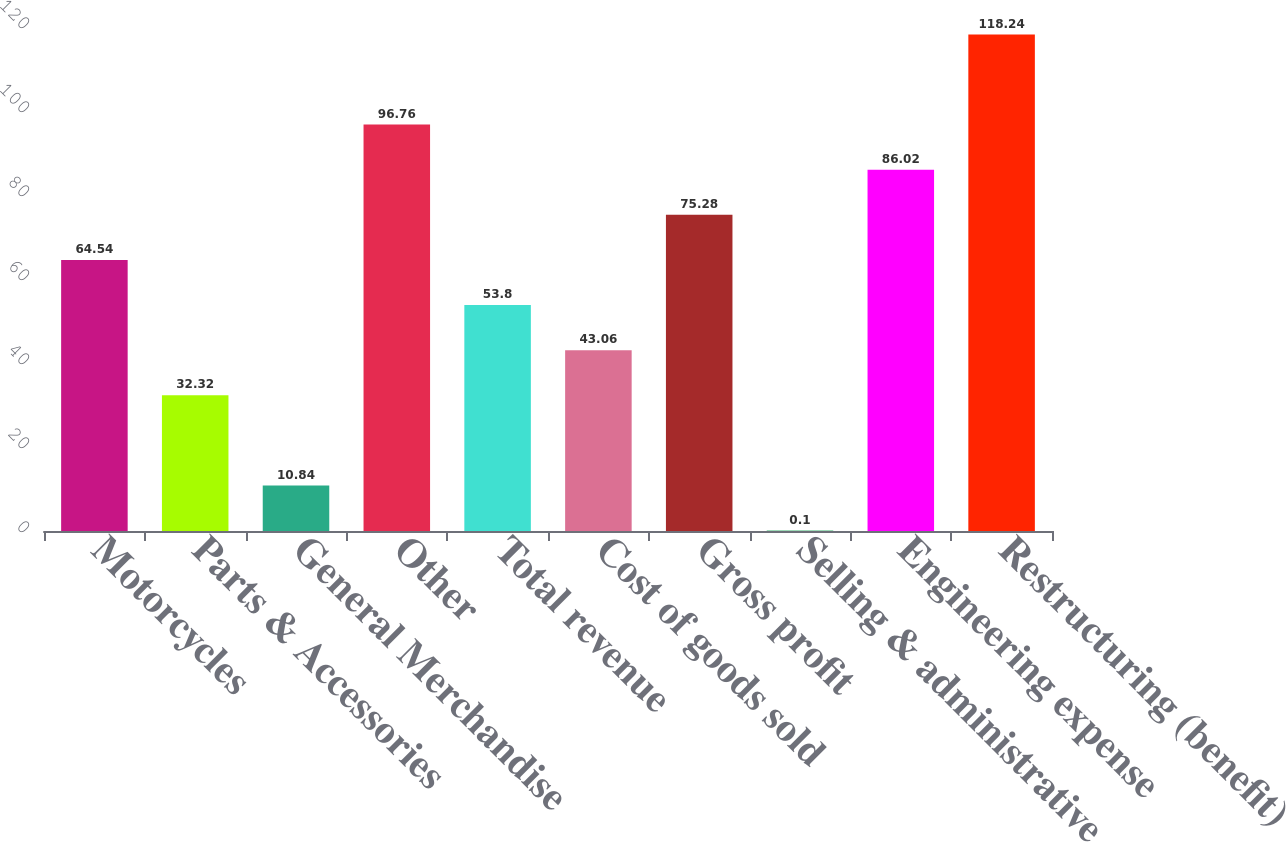Convert chart. <chart><loc_0><loc_0><loc_500><loc_500><bar_chart><fcel>Motorcycles<fcel>Parts & Accessories<fcel>General Merchandise<fcel>Other<fcel>Total revenue<fcel>Cost of goods sold<fcel>Gross profit<fcel>Selling & administrative<fcel>Engineering expense<fcel>Restructuring (benefit)<nl><fcel>64.54<fcel>32.32<fcel>10.84<fcel>96.76<fcel>53.8<fcel>43.06<fcel>75.28<fcel>0.1<fcel>86.02<fcel>118.24<nl></chart> 